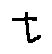<formula> <loc_0><loc_0><loc_500><loc_500>t</formula> 